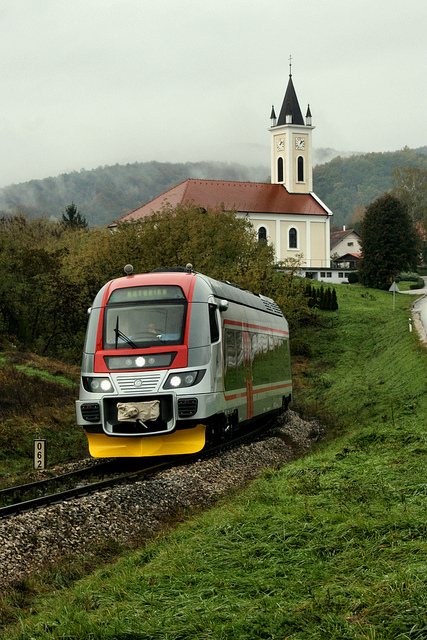Please transcribe the text in this image. 062 